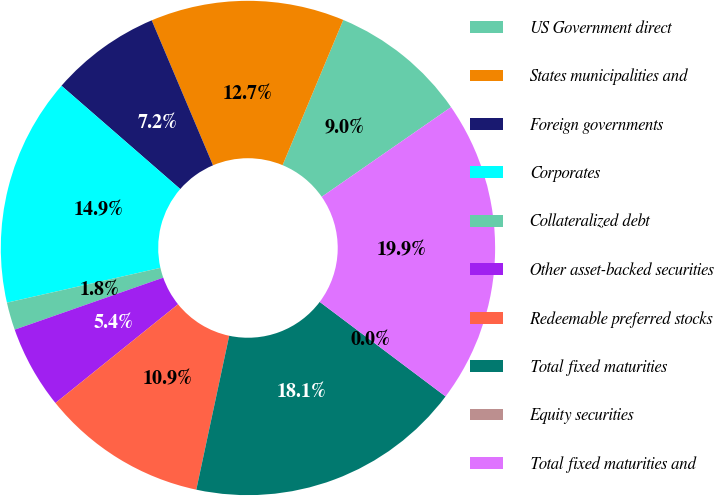Convert chart. <chart><loc_0><loc_0><loc_500><loc_500><pie_chart><fcel>US Government direct<fcel>States municipalities and<fcel>Foreign governments<fcel>Corporates<fcel>Collateralized debt<fcel>Other asset-backed securities<fcel>Redeemable preferred stocks<fcel>Total fixed maturities<fcel>Equity securities<fcel>Total fixed maturities and<nl><fcel>9.05%<fcel>12.67%<fcel>7.24%<fcel>14.95%<fcel>1.81%<fcel>5.43%<fcel>10.86%<fcel>18.1%<fcel>0.0%<fcel>19.91%<nl></chart> 